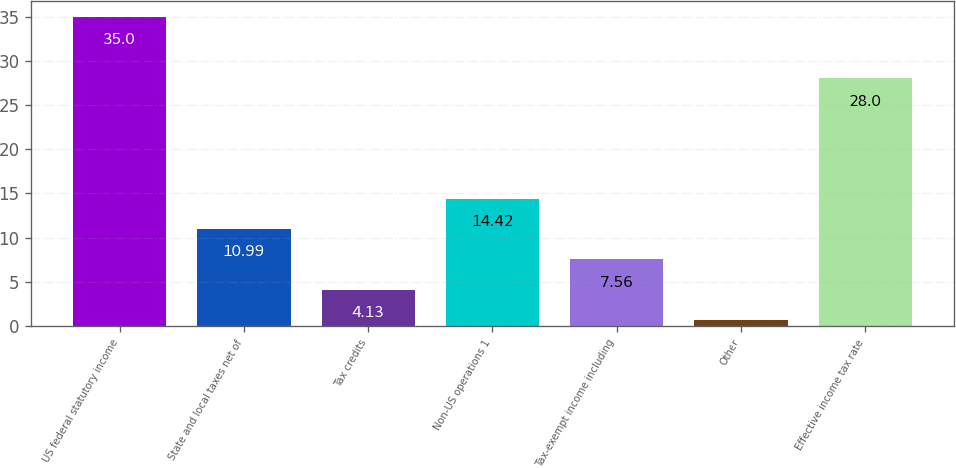Convert chart to OTSL. <chart><loc_0><loc_0><loc_500><loc_500><bar_chart><fcel>US federal statutory income<fcel>State and local taxes net of<fcel>Tax credits<fcel>Non-US operations 1<fcel>Tax-exempt income including<fcel>Other<fcel>Effective income tax rate<nl><fcel>35<fcel>10.99<fcel>4.13<fcel>14.42<fcel>7.56<fcel>0.7<fcel>28<nl></chart> 